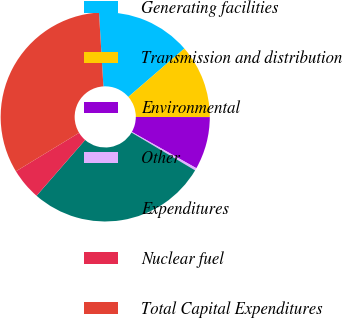Convert chart to OTSL. <chart><loc_0><loc_0><loc_500><loc_500><pie_chart><fcel>Generating facilities<fcel>Transmission and distribution<fcel>Environmental<fcel>Other<fcel>Expenditures<fcel>Nuclear fuel<fcel>Total Capital Expenditures<nl><fcel>14.61%<fcel>11.37%<fcel>8.13%<fcel>0.38%<fcel>27.86%<fcel>4.89%<fcel>32.76%<nl></chart> 